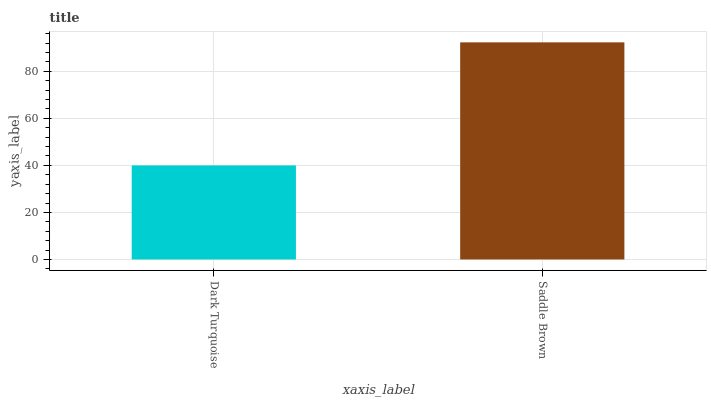Is Dark Turquoise the minimum?
Answer yes or no. Yes. Is Saddle Brown the maximum?
Answer yes or no. Yes. Is Saddle Brown the minimum?
Answer yes or no. No. Is Saddle Brown greater than Dark Turquoise?
Answer yes or no. Yes. Is Dark Turquoise less than Saddle Brown?
Answer yes or no. Yes. Is Dark Turquoise greater than Saddle Brown?
Answer yes or no. No. Is Saddle Brown less than Dark Turquoise?
Answer yes or no. No. Is Saddle Brown the high median?
Answer yes or no. Yes. Is Dark Turquoise the low median?
Answer yes or no. Yes. Is Dark Turquoise the high median?
Answer yes or no. No. Is Saddle Brown the low median?
Answer yes or no. No. 